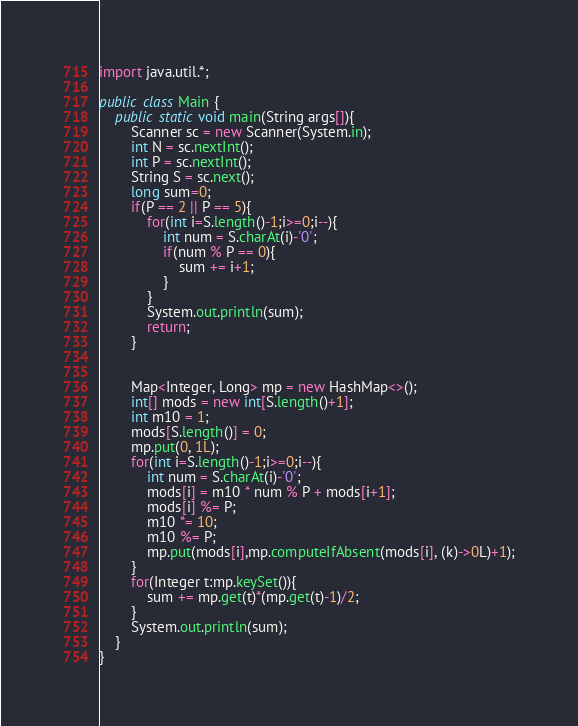Convert code to text. <code><loc_0><loc_0><loc_500><loc_500><_Java_>import java.util.*;

public class Main {
    public static void main(String args[]){
        Scanner sc = new Scanner(System.in);
        int N = sc.nextInt();
        int P = sc.nextInt();
        String S = sc.next();
        long sum=0;
        if(P == 2 || P == 5){
            for(int i=S.length()-1;i>=0;i--){
                int num = S.charAt(i)-'0';
                if(num % P == 0){
                    sum += i+1;
                }
            }
            System.out.println(sum);
            return;
        }


        Map<Integer, Long> mp = new HashMap<>();
        int[] mods = new int[S.length()+1];
        int m10 = 1;
        mods[S.length()] = 0;
        mp.put(0, 1L);
        for(int i=S.length()-1;i>=0;i--){
            int num = S.charAt(i)-'0';
            mods[i] = m10 * num % P + mods[i+1];
            mods[i] %= P;
            m10 *= 10;
            m10 %= P;
            mp.put(mods[i],mp.computeIfAbsent(mods[i], (k)->0L)+1);
        }
        for(Integer t:mp.keySet()){
            sum += mp.get(t)*(mp.get(t)-1)/2;
        }
        System.out.println(sum);
    }
}
</code> 